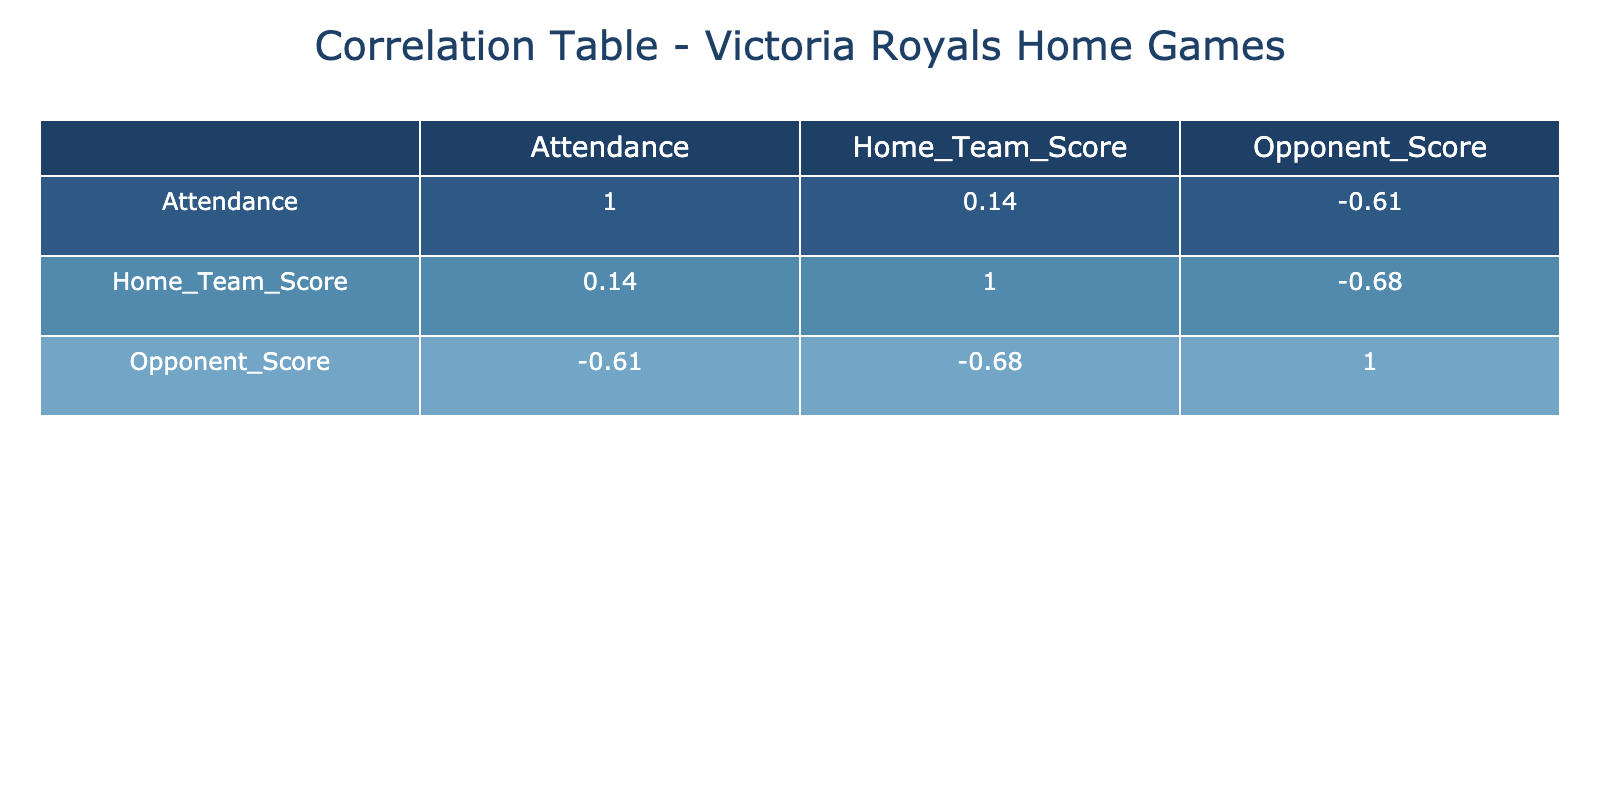What is the correlation between Attendance and Home Team Score? Looking at the correlation table, I can see the correlation value between Attendance and Home Team Score is 0.48. This indicates a moderate positive correlation, meaning that as attendance increases, the home team score tends to increase as well.
Answer: 0.48 What was the attendance for the game against the Everett Silvertips? Referring to the table, the attendance for the game on November 5 against the Everett Silvertips was 5000.
Answer: 5000 Was there a game where the Victoria Royals scored more points than the opponent and the attendance was over 4000? Checking the outcomes and attendance figures, the game on November 5 against the Everett Silvertips shows a win with a score of 6 to 1, and attendance was 5000. Thus, this statement is true.
Answer: Yes What is the average attendance for games that resulted in a win? To find the average attendance for wins, I first identify the attendance figures where the outcome was a win: 4200 (Spokane Chiefs, win), 3800 (Kootenay Ice, win), 5000 (Everett Silvertips, win), and 4100 (Portland Winterhawks, win). Adding these gives 4200 + 3800 + 5000 + 4100 = 17100. Dividing by the 4 wins gives an average attendance of 17100 / 4 = 4275.
Answer: 4275 What percentage of games resulted in a win when the attendance was 4000 or more? From the table, we look at games with attendance of 4000 or more: there are 5 games (Spokane Chiefs, Tri-City Americans, Everett Silvertips, Kootenay Ice, and Portland Winterhawks). Of these games, 3 resulted in a win (Everett Silvertips, Kootenay Ice, and Portland Winterhawks). Calculating the percentage: (3 wins / 5 total games) * 100 = 60%.
Answer: 60% 